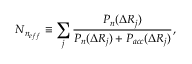<formula> <loc_0><loc_0><loc_500><loc_500>N _ { n _ { e f f } } \equiv \sum _ { j } \frac { P _ { n } ( \Delta R _ { j } ) } { P _ { n } ( \Delta R _ { j } ) + P _ { a c c } ( \Delta R _ { j } ) } ,</formula> 